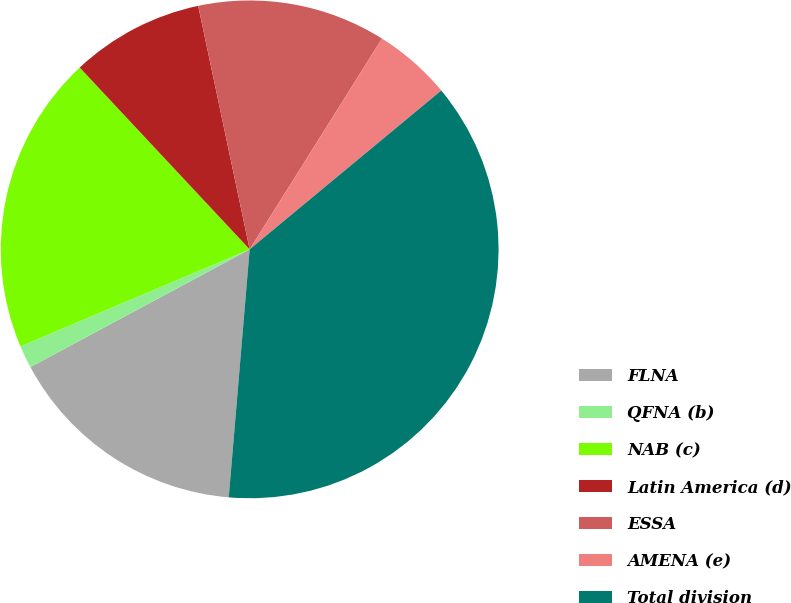Convert chart. <chart><loc_0><loc_0><loc_500><loc_500><pie_chart><fcel>FLNA<fcel>QFNA (b)<fcel>NAB (c)<fcel>Latin America (d)<fcel>ESSA<fcel>AMENA (e)<fcel>Total division<nl><fcel>15.82%<fcel>1.47%<fcel>19.41%<fcel>8.65%<fcel>12.24%<fcel>5.06%<fcel>37.36%<nl></chart> 